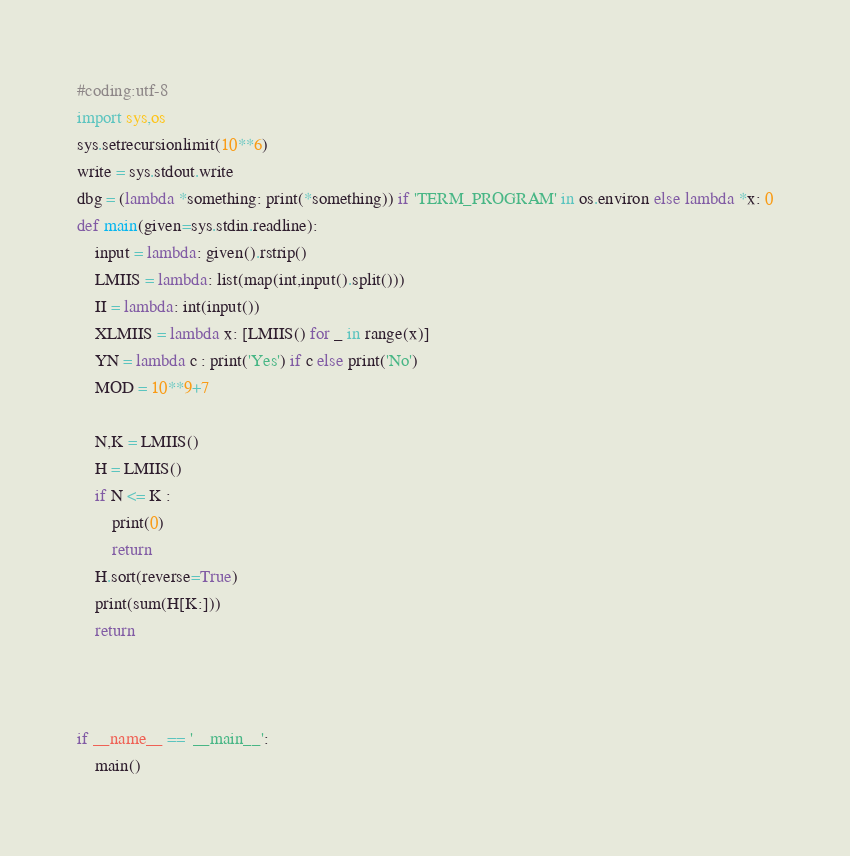Convert code to text. <code><loc_0><loc_0><loc_500><loc_500><_Python_>#coding:utf-8
import sys,os
sys.setrecursionlimit(10**6)
write = sys.stdout.write
dbg = (lambda *something: print(*something)) if 'TERM_PROGRAM' in os.environ else lambda *x: 0
def main(given=sys.stdin.readline):
    input = lambda: given().rstrip()
    LMIIS = lambda: list(map(int,input().split()))
    II = lambda: int(input())
    XLMIIS = lambda x: [LMIIS() for _ in range(x)]
    YN = lambda c : print('Yes') if c else print('No')
    MOD = 10**9+7

    N,K = LMIIS()
    H = LMIIS()
    if N <= K :
        print(0)
        return
    H.sort(reverse=True)
    print(sum(H[K:]))
    return

    

if __name__ == '__main__':
    main()</code> 